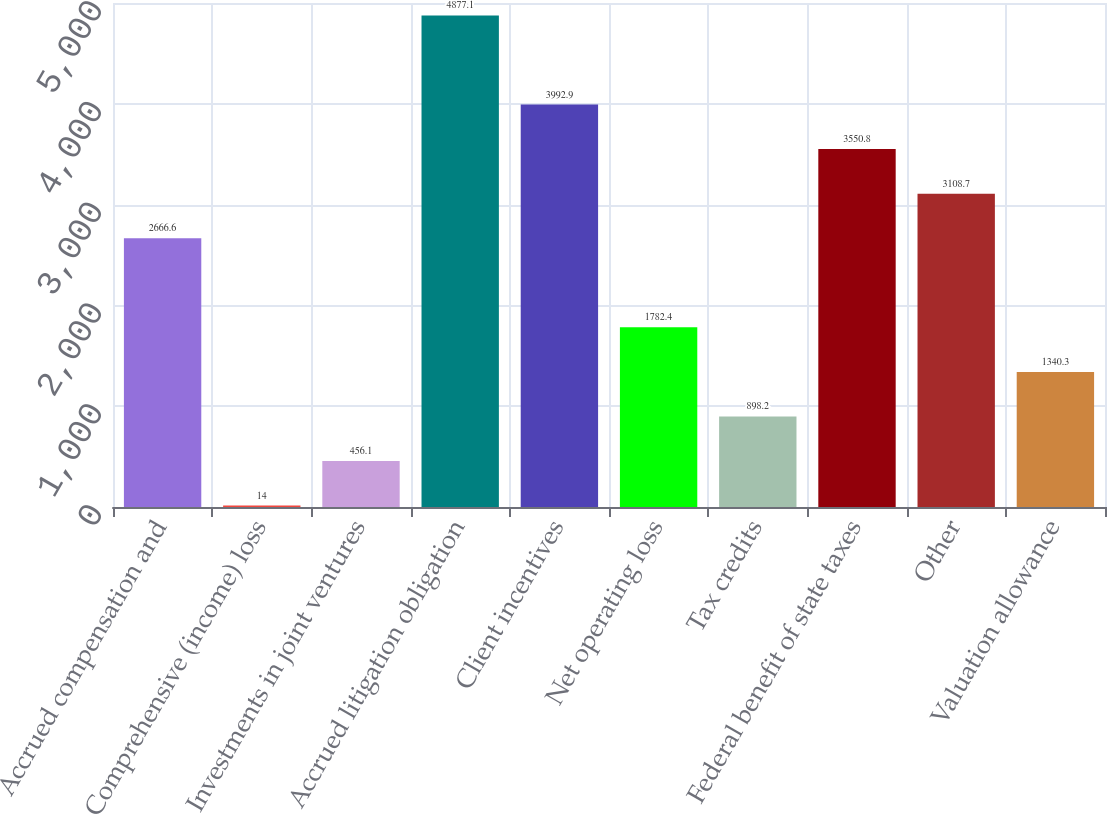<chart> <loc_0><loc_0><loc_500><loc_500><bar_chart><fcel>Accrued compensation and<fcel>Comprehensive (income) loss<fcel>Investments in joint ventures<fcel>Accrued litigation obligation<fcel>Client incentives<fcel>Net operating loss<fcel>Tax credits<fcel>Federal benefit of state taxes<fcel>Other<fcel>Valuation allowance<nl><fcel>2666.6<fcel>14<fcel>456.1<fcel>4877.1<fcel>3992.9<fcel>1782.4<fcel>898.2<fcel>3550.8<fcel>3108.7<fcel>1340.3<nl></chart> 